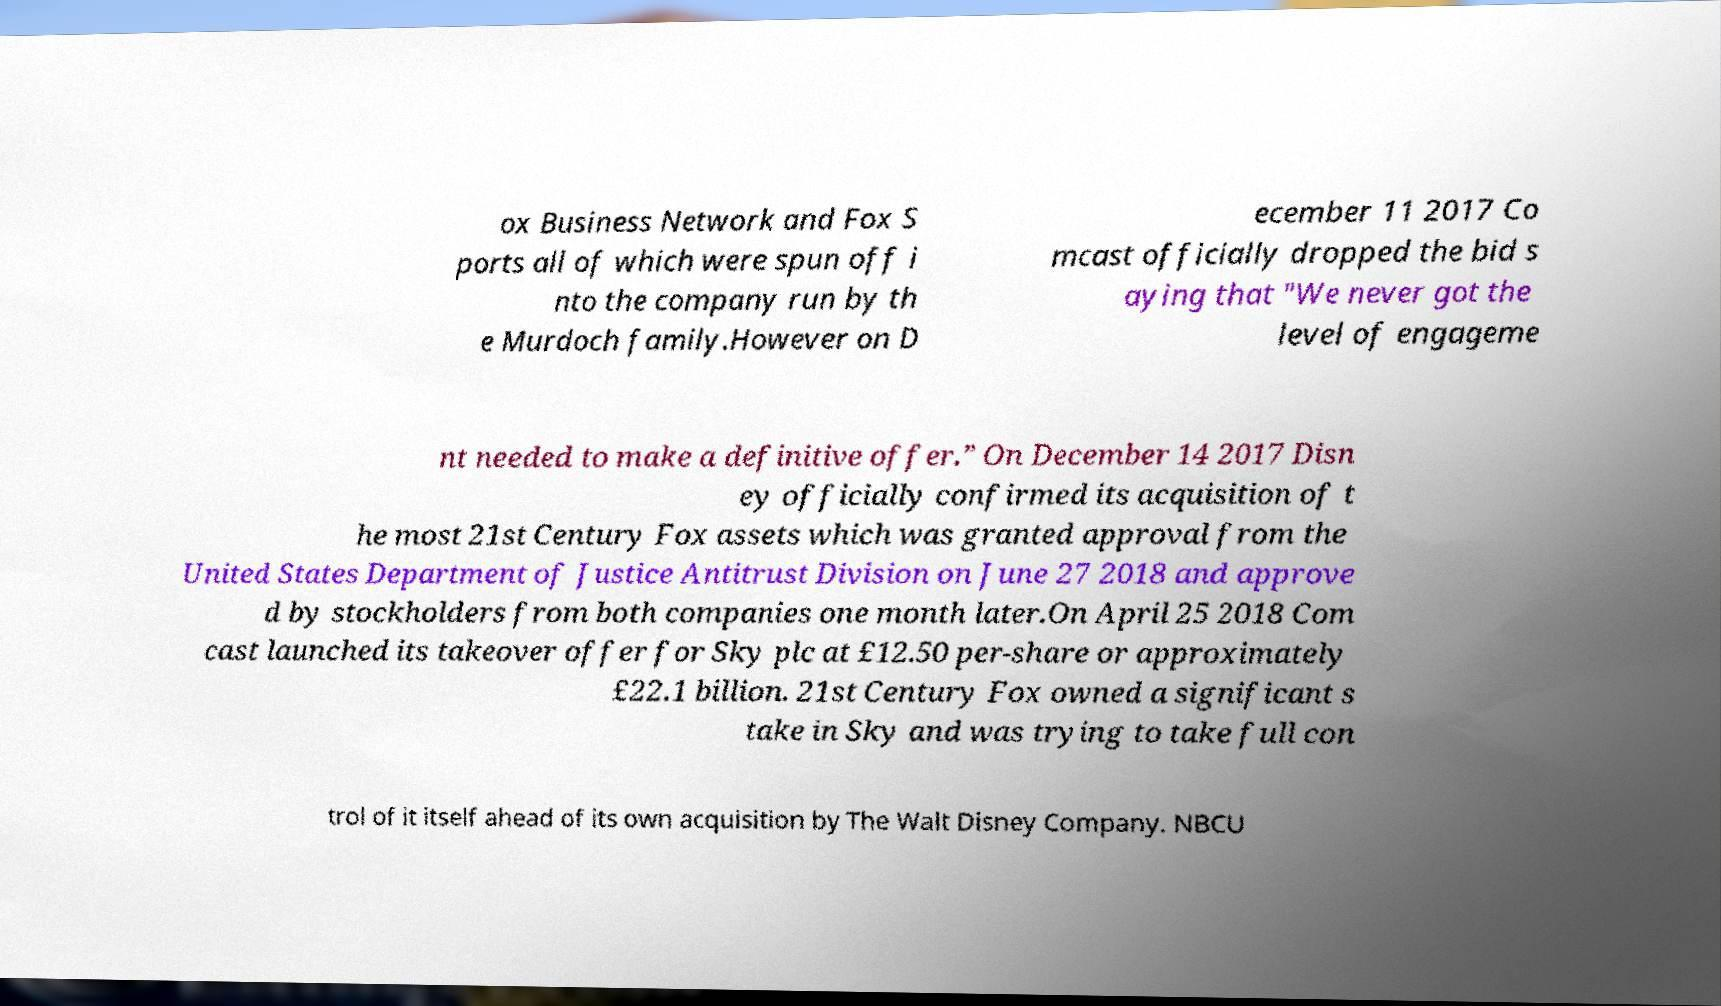I need the written content from this picture converted into text. Can you do that? ox Business Network and Fox S ports all of which were spun off i nto the company run by th e Murdoch family.However on D ecember 11 2017 Co mcast officially dropped the bid s aying that "We never got the level of engageme nt needed to make a definitive offer.” On December 14 2017 Disn ey officially confirmed its acquisition of t he most 21st Century Fox assets which was granted approval from the United States Department of Justice Antitrust Division on June 27 2018 and approve d by stockholders from both companies one month later.On April 25 2018 Com cast launched its takeover offer for Sky plc at £12.50 per-share or approximately £22.1 billion. 21st Century Fox owned a significant s take in Sky and was trying to take full con trol of it itself ahead of its own acquisition by The Walt Disney Company. NBCU 